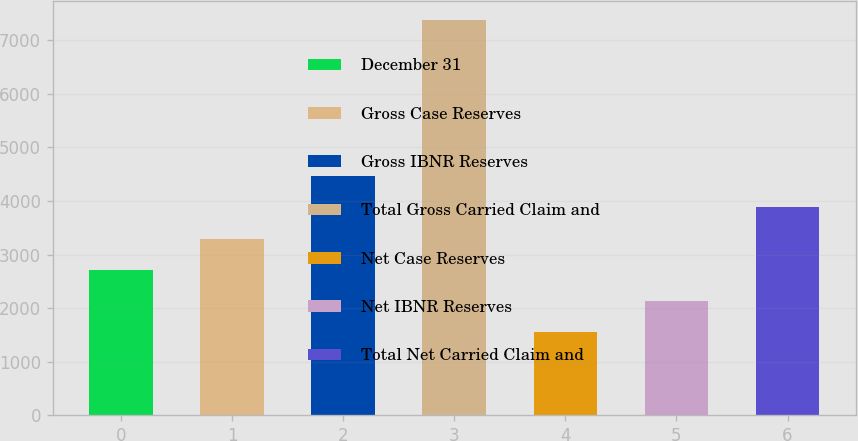Convert chart to OTSL. <chart><loc_0><loc_0><loc_500><loc_500><bar_chart><fcel>December 31<fcel>Gross Case Reserves<fcel>Gross IBNR Reserves<fcel>Total Gross Carried Claim and<fcel>Net Case Reserves<fcel>Net IBNR Reserves<fcel>Total Net Carried Claim and<nl><fcel>2717.6<fcel>3299.4<fcel>4463<fcel>7372<fcel>1554<fcel>2135.8<fcel>3881.2<nl></chart> 